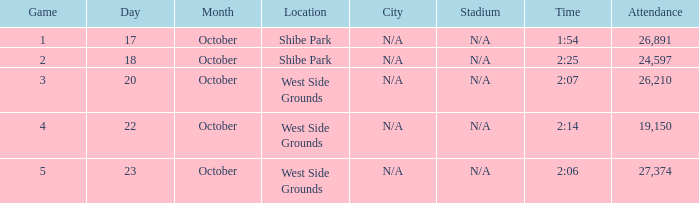Which week was the first game played that had a time of 2:06 and less than 27,374 attendees? None. Give me the full table as a dictionary. {'header': ['Game', 'Day', 'Month', 'Location', 'City', 'Stadium', 'Time', 'Attendance'], 'rows': [['1', '17', 'October', 'Shibe Park', 'N/A', 'N/A', '1:54', '26,891'], ['2', '18', 'October', 'Shibe Park', 'N/A', 'N/A', '2:25', '24,597'], ['3', '20', 'October', 'West Side Grounds', 'N/A', 'N/A', '2:07', '26,210'], ['4', '22', 'October', 'West Side Grounds', 'N/A', 'N/A', '2:14', '19,150'], ['5', '23', 'October', 'West Side Grounds', 'N/A', 'N/A', '2:06', '27,374']]} 